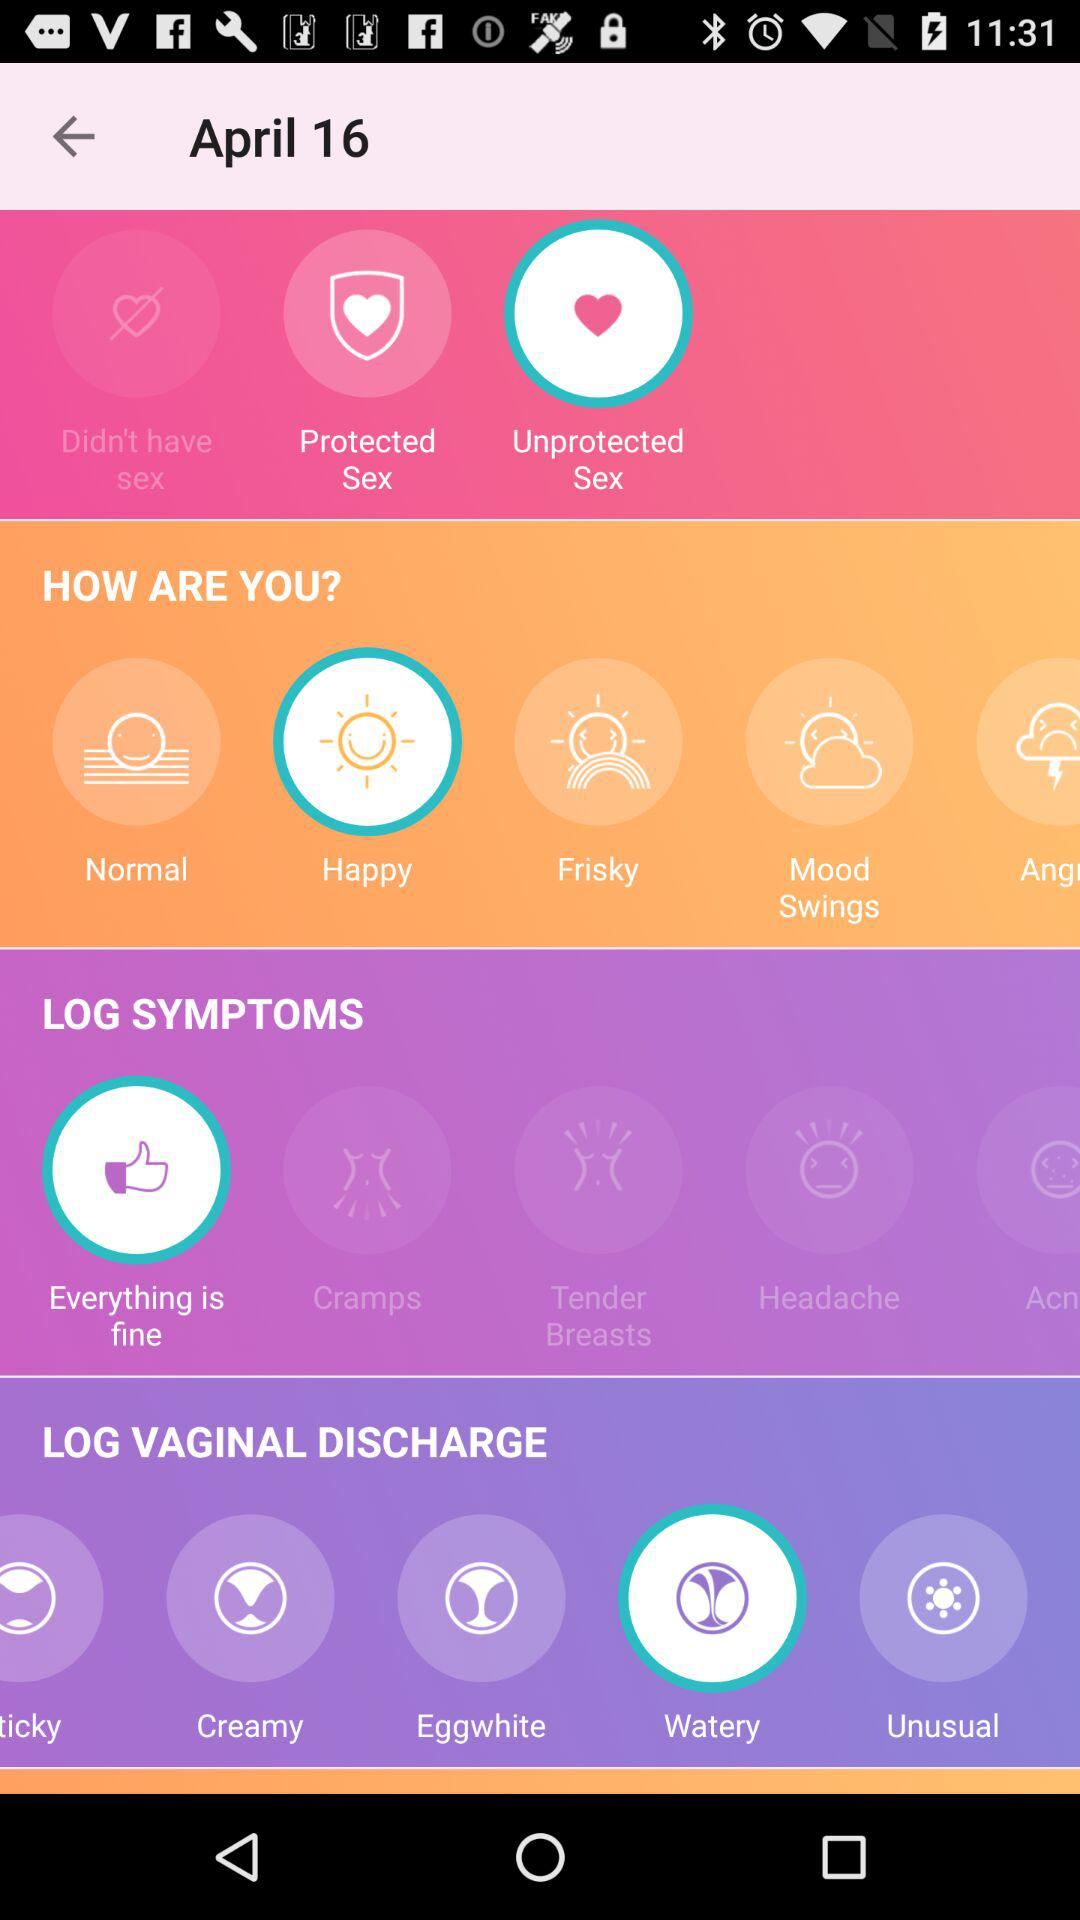What is the mentioned date? The mentioned date is April 16. 